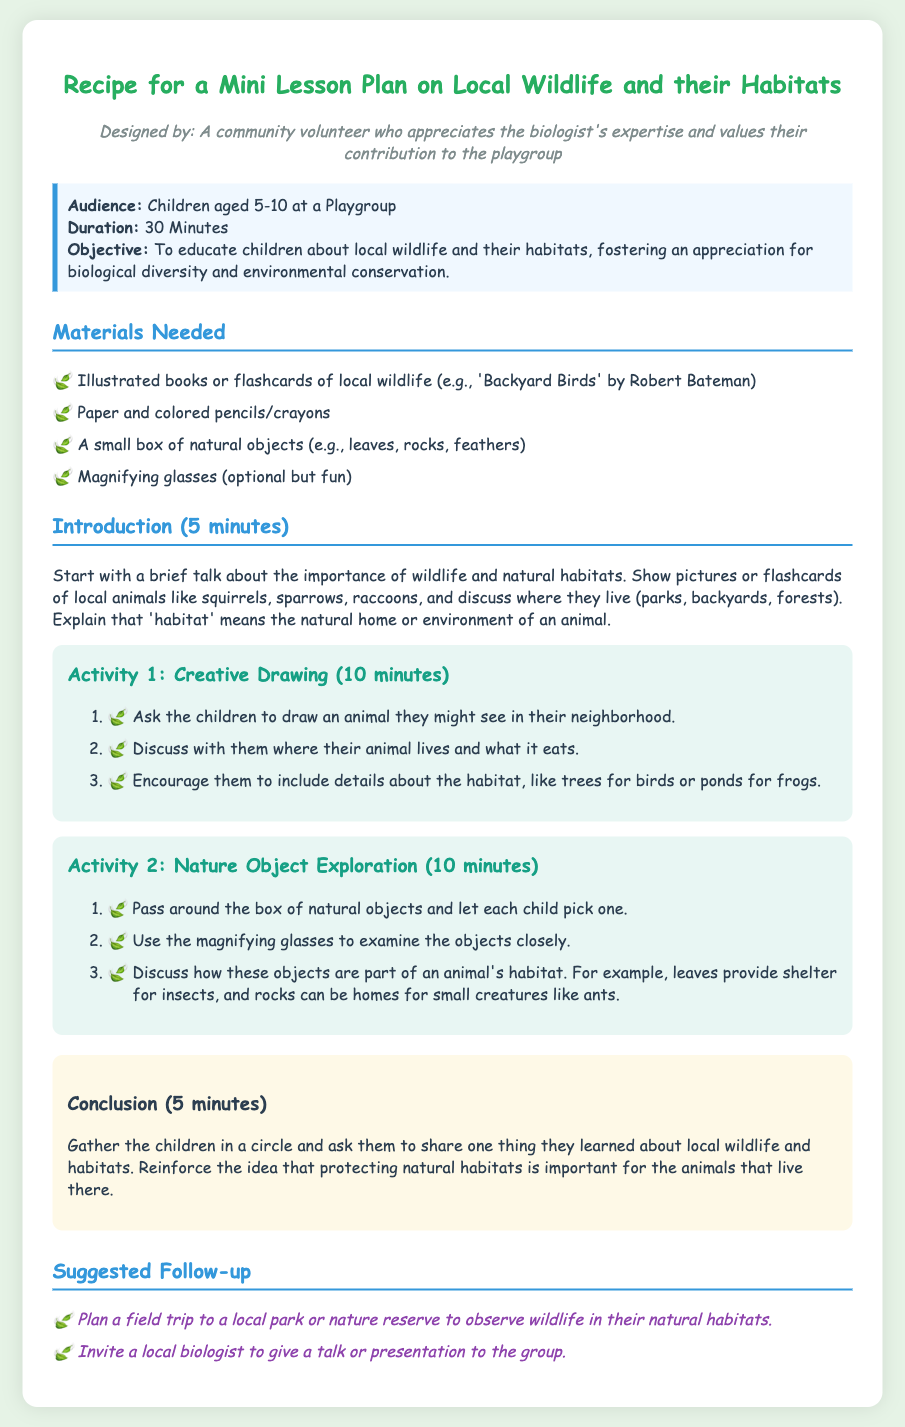What is the target audience for the lesson plan? The audience is specified as children aged 5-10 at a Playgroup, which reflects the intended participants for the lesson.
Answer: Children aged 5-10 How long is the lesson plan designed to last? The document clearly states that the duration of the lesson plan is 30 minutes, indicating the time allocated for the activities.
Answer: 30 Minutes What is the first activity in the lesson plan? The document lists "Creative Drawing" as the first activity, which is intended to engage children in expressing their understanding.
Answer: Creative Drawing How much time is allocated for the conclusion? The conclusion section specifies that 5 minutes are allotted for summarizing and sharing learnings, indicating the time focus for this part of the lesson.
Answer: 5 minutes What materials are needed for the lesson plan? The document outlines a list of materials needed, including illustrated books or flashcards of local wildlife, which are key resources for the lesson.
Answer: Illustrated books or flashcards of local wildlife What is one suggested follow-up activity mentioned in the document? The document suggests planning a field trip to a local park or nature reserve, which is an option for extending the children's learning experience about wildlife.
Answer: Field trip to a local park or nature reserve What is the objective of the lesson plan? The objective is described as educating children about local wildlife and their habitats, aiming to foster appreciation for biological diversity and conservation.
Answer: Educate children about local wildlife and their habitats Which natural objects are included in the exploration activity? The activity mentions a small box of natural objects, including leaves, rocks, and feathers, which are used for encouraging exploration in the lesson.
Answer: Leaves, rocks, feathers 